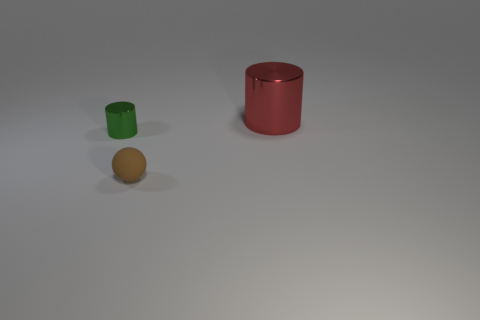Add 1 cylinders. How many objects exist? 4 Subtract all cylinders. How many objects are left? 1 Subtract all tiny brown metallic things. Subtract all brown matte things. How many objects are left? 2 Add 3 metallic cylinders. How many metallic cylinders are left? 5 Add 1 yellow shiny balls. How many yellow shiny balls exist? 1 Subtract 0 blue blocks. How many objects are left? 3 